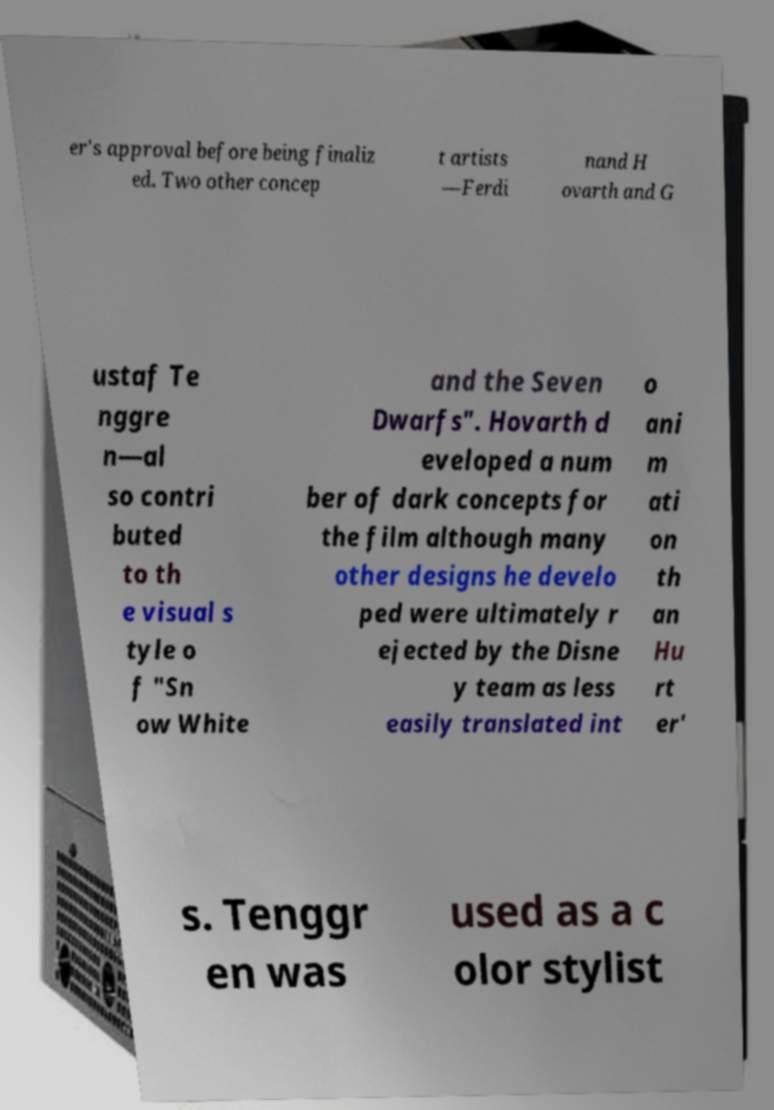For documentation purposes, I need the text within this image transcribed. Could you provide that? er's approval before being finaliz ed. Two other concep t artists —Ferdi nand H ovarth and G ustaf Te nggre n—al so contri buted to th e visual s tyle o f "Sn ow White and the Seven Dwarfs". Hovarth d eveloped a num ber of dark concepts for the film although many other designs he develo ped were ultimately r ejected by the Disne y team as less easily translated int o ani m ati on th an Hu rt er' s. Tenggr en was used as a c olor stylist 